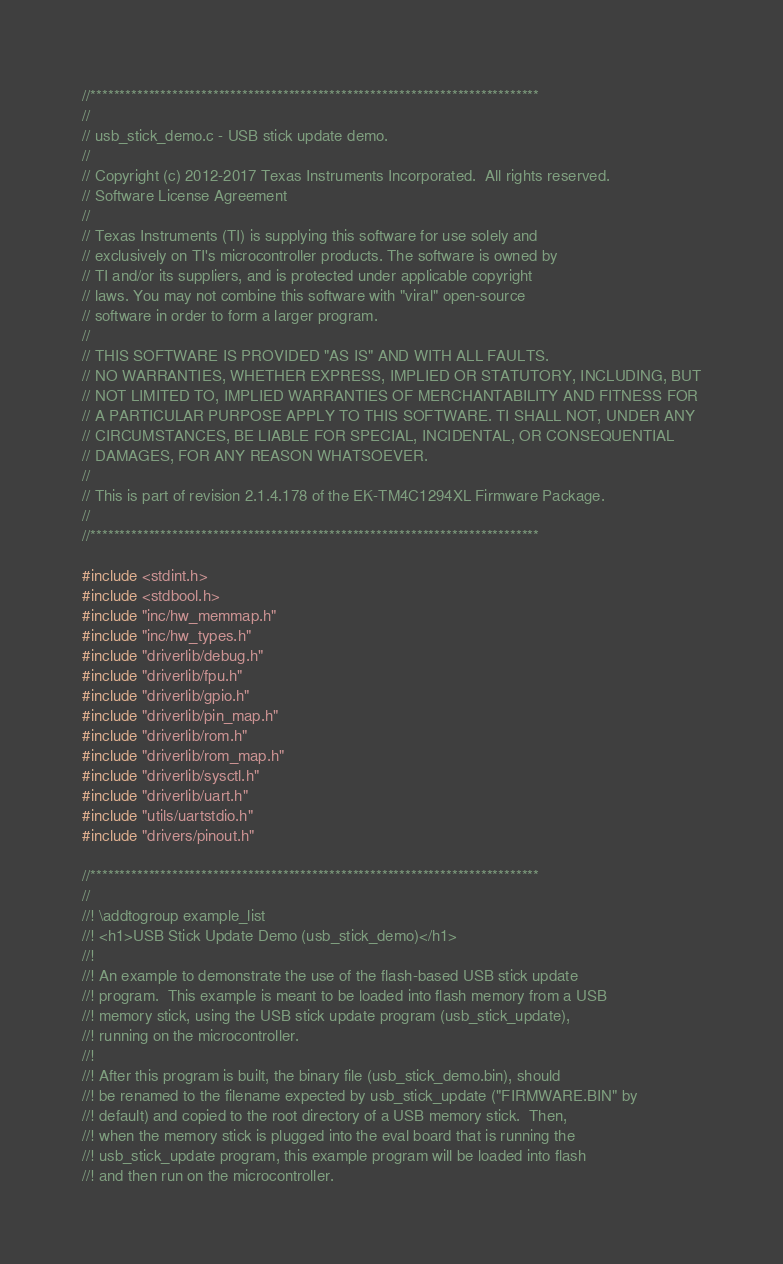<code> <loc_0><loc_0><loc_500><loc_500><_C_>//*****************************************************************************
//
// usb_stick_demo.c - USB stick update demo.
//
// Copyright (c) 2012-2017 Texas Instruments Incorporated.  All rights reserved.
// Software License Agreement
// 
// Texas Instruments (TI) is supplying this software for use solely and
// exclusively on TI's microcontroller products. The software is owned by
// TI and/or its suppliers, and is protected under applicable copyright
// laws. You may not combine this software with "viral" open-source
// software in order to form a larger program.
// 
// THIS SOFTWARE IS PROVIDED "AS IS" AND WITH ALL FAULTS.
// NO WARRANTIES, WHETHER EXPRESS, IMPLIED OR STATUTORY, INCLUDING, BUT
// NOT LIMITED TO, IMPLIED WARRANTIES OF MERCHANTABILITY AND FITNESS FOR
// A PARTICULAR PURPOSE APPLY TO THIS SOFTWARE. TI SHALL NOT, UNDER ANY
// CIRCUMSTANCES, BE LIABLE FOR SPECIAL, INCIDENTAL, OR CONSEQUENTIAL
// DAMAGES, FOR ANY REASON WHATSOEVER.
// 
// This is part of revision 2.1.4.178 of the EK-TM4C1294XL Firmware Package.
//
//*****************************************************************************

#include <stdint.h>
#include <stdbool.h>
#include "inc/hw_memmap.h"
#include "inc/hw_types.h"
#include "driverlib/debug.h"
#include "driverlib/fpu.h"
#include "driverlib/gpio.h"
#include "driverlib/pin_map.h"
#include "driverlib/rom.h"
#include "driverlib/rom_map.h"
#include "driverlib/sysctl.h"
#include "driverlib/uart.h"
#include "utils/uartstdio.h"
#include "drivers/pinout.h"

//*****************************************************************************
//
//! \addtogroup example_list
//! <h1>USB Stick Update Demo (usb_stick_demo)</h1>
//!
//! An example to demonstrate the use of the flash-based USB stick update
//! program.  This example is meant to be loaded into flash memory from a USB
//! memory stick, using the USB stick update program (usb_stick_update),
//! running on the microcontroller.
//!
//! After this program is built, the binary file (usb_stick_demo.bin), should
//! be renamed to the filename expected by usb_stick_update ("FIRMWARE.BIN" by
//! default) and copied to the root directory of a USB memory stick.  Then,
//! when the memory stick is plugged into the eval board that is running the
//! usb_stick_update program, this example program will be loaded into flash
//! and then run on the microcontroller.</code> 